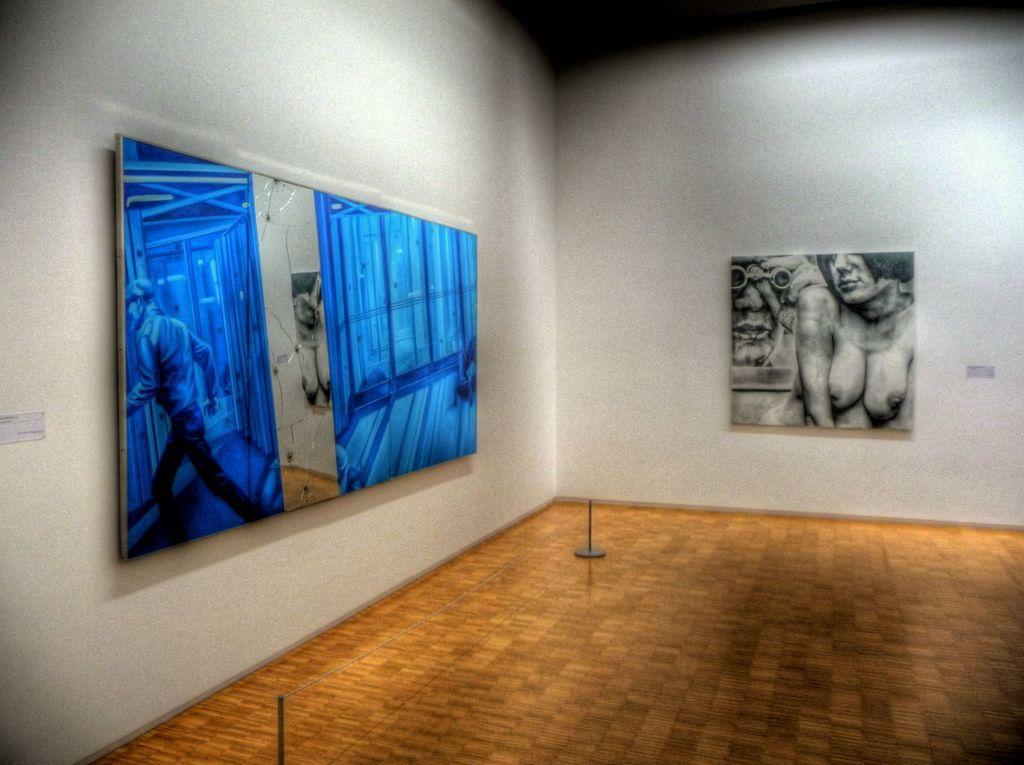In one or two sentences, can you explain what this image depicts? In the picture we can see a wooden floor and in the walls we can see paintings and on one we can see a nude woman and another we can see a blue color frame and a man walking it, and beside it we can see a switch. 